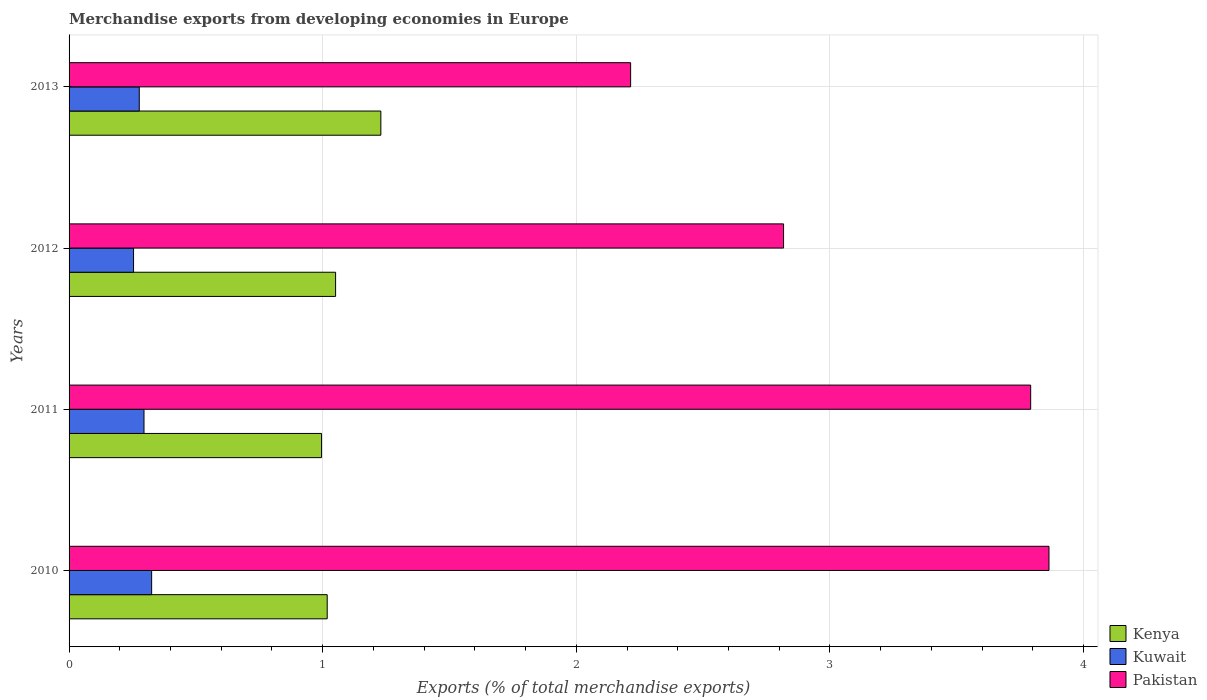How many different coloured bars are there?
Offer a very short reply. 3. Are the number of bars per tick equal to the number of legend labels?
Keep it short and to the point. Yes. How many bars are there on the 3rd tick from the bottom?
Your response must be concise. 3. What is the percentage of total merchandise exports in Pakistan in 2013?
Give a very brief answer. 2.21. Across all years, what is the maximum percentage of total merchandise exports in Kenya?
Offer a terse response. 1.23. Across all years, what is the minimum percentage of total merchandise exports in Kenya?
Give a very brief answer. 1. In which year was the percentage of total merchandise exports in Kuwait maximum?
Keep it short and to the point. 2010. In which year was the percentage of total merchandise exports in Kenya minimum?
Ensure brevity in your answer.  2011. What is the total percentage of total merchandise exports in Pakistan in the graph?
Your response must be concise. 12.69. What is the difference between the percentage of total merchandise exports in Kuwait in 2011 and that in 2012?
Ensure brevity in your answer.  0.04. What is the difference between the percentage of total merchandise exports in Kuwait in 2010 and the percentage of total merchandise exports in Kenya in 2012?
Your response must be concise. -0.73. What is the average percentage of total merchandise exports in Kenya per year?
Keep it short and to the point. 1.07. In the year 2013, what is the difference between the percentage of total merchandise exports in Kenya and percentage of total merchandise exports in Kuwait?
Provide a succinct answer. 0.95. In how many years, is the percentage of total merchandise exports in Kenya greater than 3.2 %?
Your answer should be compact. 0. What is the ratio of the percentage of total merchandise exports in Pakistan in 2012 to that in 2013?
Your answer should be very brief. 1.27. What is the difference between the highest and the second highest percentage of total merchandise exports in Kuwait?
Give a very brief answer. 0.03. What is the difference between the highest and the lowest percentage of total merchandise exports in Kenya?
Provide a succinct answer. 0.23. Is the sum of the percentage of total merchandise exports in Kenya in 2011 and 2012 greater than the maximum percentage of total merchandise exports in Kuwait across all years?
Provide a short and direct response. Yes. What does the 3rd bar from the top in 2013 represents?
Your answer should be compact. Kenya. What does the 3rd bar from the bottom in 2011 represents?
Offer a very short reply. Pakistan. Is it the case that in every year, the sum of the percentage of total merchandise exports in Kenya and percentage of total merchandise exports in Kuwait is greater than the percentage of total merchandise exports in Pakistan?
Provide a succinct answer. No. Are all the bars in the graph horizontal?
Provide a succinct answer. Yes. What is the difference between two consecutive major ticks on the X-axis?
Make the answer very short. 1. Are the values on the major ticks of X-axis written in scientific E-notation?
Make the answer very short. No. How are the legend labels stacked?
Your answer should be very brief. Vertical. What is the title of the graph?
Make the answer very short. Merchandise exports from developing economies in Europe. Does "Turks and Caicos Islands" appear as one of the legend labels in the graph?
Provide a short and direct response. No. What is the label or title of the X-axis?
Offer a terse response. Exports (% of total merchandise exports). What is the label or title of the Y-axis?
Ensure brevity in your answer.  Years. What is the Exports (% of total merchandise exports) in Kenya in 2010?
Keep it short and to the point. 1.02. What is the Exports (% of total merchandise exports) of Kuwait in 2010?
Give a very brief answer. 0.33. What is the Exports (% of total merchandise exports) in Pakistan in 2010?
Give a very brief answer. 3.86. What is the Exports (% of total merchandise exports) in Kenya in 2011?
Provide a succinct answer. 1. What is the Exports (% of total merchandise exports) in Kuwait in 2011?
Your response must be concise. 0.3. What is the Exports (% of total merchandise exports) of Pakistan in 2011?
Your answer should be compact. 3.79. What is the Exports (% of total merchandise exports) of Kenya in 2012?
Your response must be concise. 1.05. What is the Exports (% of total merchandise exports) in Kuwait in 2012?
Keep it short and to the point. 0.25. What is the Exports (% of total merchandise exports) of Pakistan in 2012?
Offer a very short reply. 2.82. What is the Exports (% of total merchandise exports) in Kenya in 2013?
Your response must be concise. 1.23. What is the Exports (% of total merchandise exports) in Kuwait in 2013?
Offer a terse response. 0.28. What is the Exports (% of total merchandise exports) of Pakistan in 2013?
Your answer should be compact. 2.21. Across all years, what is the maximum Exports (% of total merchandise exports) of Kenya?
Keep it short and to the point. 1.23. Across all years, what is the maximum Exports (% of total merchandise exports) of Kuwait?
Offer a very short reply. 0.33. Across all years, what is the maximum Exports (% of total merchandise exports) in Pakistan?
Provide a short and direct response. 3.86. Across all years, what is the minimum Exports (% of total merchandise exports) in Kenya?
Make the answer very short. 1. Across all years, what is the minimum Exports (% of total merchandise exports) of Kuwait?
Offer a very short reply. 0.25. Across all years, what is the minimum Exports (% of total merchandise exports) of Pakistan?
Your answer should be compact. 2.21. What is the total Exports (% of total merchandise exports) of Kenya in the graph?
Provide a short and direct response. 4.29. What is the total Exports (% of total merchandise exports) in Kuwait in the graph?
Offer a very short reply. 1.15. What is the total Exports (% of total merchandise exports) of Pakistan in the graph?
Make the answer very short. 12.69. What is the difference between the Exports (% of total merchandise exports) of Kenya in 2010 and that in 2011?
Your answer should be very brief. 0.02. What is the difference between the Exports (% of total merchandise exports) in Kuwait in 2010 and that in 2011?
Your answer should be compact. 0.03. What is the difference between the Exports (% of total merchandise exports) in Pakistan in 2010 and that in 2011?
Provide a short and direct response. 0.07. What is the difference between the Exports (% of total merchandise exports) of Kenya in 2010 and that in 2012?
Offer a very short reply. -0.03. What is the difference between the Exports (% of total merchandise exports) in Kuwait in 2010 and that in 2012?
Your answer should be compact. 0.07. What is the difference between the Exports (% of total merchandise exports) in Pakistan in 2010 and that in 2012?
Offer a very short reply. 1.05. What is the difference between the Exports (% of total merchandise exports) in Kenya in 2010 and that in 2013?
Give a very brief answer. -0.21. What is the difference between the Exports (% of total merchandise exports) in Kuwait in 2010 and that in 2013?
Offer a terse response. 0.05. What is the difference between the Exports (% of total merchandise exports) in Pakistan in 2010 and that in 2013?
Provide a short and direct response. 1.65. What is the difference between the Exports (% of total merchandise exports) of Kenya in 2011 and that in 2012?
Provide a short and direct response. -0.06. What is the difference between the Exports (% of total merchandise exports) in Kuwait in 2011 and that in 2012?
Provide a succinct answer. 0.04. What is the difference between the Exports (% of total merchandise exports) in Pakistan in 2011 and that in 2012?
Your response must be concise. 0.97. What is the difference between the Exports (% of total merchandise exports) in Kenya in 2011 and that in 2013?
Your response must be concise. -0.23. What is the difference between the Exports (% of total merchandise exports) of Kuwait in 2011 and that in 2013?
Your answer should be compact. 0.02. What is the difference between the Exports (% of total merchandise exports) of Pakistan in 2011 and that in 2013?
Ensure brevity in your answer.  1.58. What is the difference between the Exports (% of total merchandise exports) of Kenya in 2012 and that in 2013?
Give a very brief answer. -0.18. What is the difference between the Exports (% of total merchandise exports) in Kuwait in 2012 and that in 2013?
Give a very brief answer. -0.02. What is the difference between the Exports (% of total merchandise exports) of Pakistan in 2012 and that in 2013?
Give a very brief answer. 0.6. What is the difference between the Exports (% of total merchandise exports) in Kenya in 2010 and the Exports (% of total merchandise exports) in Kuwait in 2011?
Keep it short and to the point. 0.72. What is the difference between the Exports (% of total merchandise exports) of Kenya in 2010 and the Exports (% of total merchandise exports) of Pakistan in 2011?
Make the answer very short. -2.77. What is the difference between the Exports (% of total merchandise exports) of Kuwait in 2010 and the Exports (% of total merchandise exports) of Pakistan in 2011?
Make the answer very short. -3.47. What is the difference between the Exports (% of total merchandise exports) of Kenya in 2010 and the Exports (% of total merchandise exports) of Kuwait in 2012?
Provide a succinct answer. 0.76. What is the difference between the Exports (% of total merchandise exports) of Kenya in 2010 and the Exports (% of total merchandise exports) of Pakistan in 2012?
Your answer should be very brief. -1.8. What is the difference between the Exports (% of total merchandise exports) of Kuwait in 2010 and the Exports (% of total merchandise exports) of Pakistan in 2012?
Your answer should be very brief. -2.49. What is the difference between the Exports (% of total merchandise exports) of Kenya in 2010 and the Exports (% of total merchandise exports) of Kuwait in 2013?
Ensure brevity in your answer.  0.74. What is the difference between the Exports (% of total merchandise exports) in Kenya in 2010 and the Exports (% of total merchandise exports) in Pakistan in 2013?
Offer a terse response. -1.2. What is the difference between the Exports (% of total merchandise exports) of Kuwait in 2010 and the Exports (% of total merchandise exports) of Pakistan in 2013?
Offer a very short reply. -1.89. What is the difference between the Exports (% of total merchandise exports) of Kenya in 2011 and the Exports (% of total merchandise exports) of Kuwait in 2012?
Offer a very short reply. 0.74. What is the difference between the Exports (% of total merchandise exports) in Kenya in 2011 and the Exports (% of total merchandise exports) in Pakistan in 2012?
Make the answer very short. -1.82. What is the difference between the Exports (% of total merchandise exports) in Kuwait in 2011 and the Exports (% of total merchandise exports) in Pakistan in 2012?
Provide a succinct answer. -2.52. What is the difference between the Exports (% of total merchandise exports) of Kenya in 2011 and the Exports (% of total merchandise exports) of Kuwait in 2013?
Provide a short and direct response. 0.72. What is the difference between the Exports (% of total merchandise exports) in Kenya in 2011 and the Exports (% of total merchandise exports) in Pakistan in 2013?
Your response must be concise. -1.22. What is the difference between the Exports (% of total merchandise exports) in Kuwait in 2011 and the Exports (% of total merchandise exports) in Pakistan in 2013?
Your answer should be very brief. -1.92. What is the difference between the Exports (% of total merchandise exports) in Kenya in 2012 and the Exports (% of total merchandise exports) in Kuwait in 2013?
Your answer should be very brief. 0.77. What is the difference between the Exports (% of total merchandise exports) of Kenya in 2012 and the Exports (% of total merchandise exports) of Pakistan in 2013?
Ensure brevity in your answer.  -1.16. What is the difference between the Exports (% of total merchandise exports) in Kuwait in 2012 and the Exports (% of total merchandise exports) in Pakistan in 2013?
Your answer should be compact. -1.96. What is the average Exports (% of total merchandise exports) of Kenya per year?
Give a very brief answer. 1.07. What is the average Exports (% of total merchandise exports) of Kuwait per year?
Ensure brevity in your answer.  0.29. What is the average Exports (% of total merchandise exports) in Pakistan per year?
Your answer should be compact. 3.17. In the year 2010, what is the difference between the Exports (% of total merchandise exports) in Kenya and Exports (% of total merchandise exports) in Kuwait?
Your response must be concise. 0.69. In the year 2010, what is the difference between the Exports (% of total merchandise exports) of Kenya and Exports (% of total merchandise exports) of Pakistan?
Provide a succinct answer. -2.85. In the year 2010, what is the difference between the Exports (% of total merchandise exports) of Kuwait and Exports (% of total merchandise exports) of Pakistan?
Give a very brief answer. -3.54. In the year 2011, what is the difference between the Exports (% of total merchandise exports) in Kenya and Exports (% of total merchandise exports) in Pakistan?
Keep it short and to the point. -2.8. In the year 2011, what is the difference between the Exports (% of total merchandise exports) in Kuwait and Exports (% of total merchandise exports) in Pakistan?
Ensure brevity in your answer.  -3.5. In the year 2012, what is the difference between the Exports (% of total merchandise exports) of Kenya and Exports (% of total merchandise exports) of Kuwait?
Ensure brevity in your answer.  0.8. In the year 2012, what is the difference between the Exports (% of total merchandise exports) in Kenya and Exports (% of total merchandise exports) in Pakistan?
Keep it short and to the point. -1.77. In the year 2012, what is the difference between the Exports (% of total merchandise exports) in Kuwait and Exports (% of total merchandise exports) in Pakistan?
Offer a very short reply. -2.56. In the year 2013, what is the difference between the Exports (% of total merchandise exports) in Kenya and Exports (% of total merchandise exports) in Kuwait?
Make the answer very short. 0.95. In the year 2013, what is the difference between the Exports (% of total merchandise exports) of Kenya and Exports (% of total merchandise exports) of Pakistan?
Ensure brevity in your answer.  -0.98. In the year 2013, what is the difference between the Exports (% of total merchandise exports) of Kuwait and Exports (% of total merchandise exports) of Pakistan?
Ensure brevity in your answer.  -1.94. What is the ratio of the Exports (% of total merchandise exports) of Kenya in 2010 to that in 2011?
Give a very brief answer. 1.02. What is the ratio of the Exports (% of total merchandise exports) of Kuwait in 2010 to that in 2011?
Make the answer very short. 1.1. What is the ratio of the Exports (% of total merchandise exports) in Kenya in 2010 to that in 2012?
Your answer should be very brief. 0.97. What is the ratio of the Exports (% of total merchandise exports) of Kuwait in 2010 to that in 2012?
Your answer should be compact. 1.28. What is the ratio of the Exports (% of total merchandise exports) in Pakistan in 2010 to that in 2012?
Offer a terse response. 1.37. What is the ratio of the Exports (% of total merchandise exports) of Kenya in 2010 to that in 2013?
Ensure brevity in your answer.  0.83. What is the ratio of the Exports (% of total merchandise exports) of Kuwait in 2010 to that in 2013?
Your response must be concise. 1.18. What is the ratio of the Exports (% of total merchandise exports) in Pakistan in 2010 to that in 2013?
Keep it short and to the point. 1.75. What is the ratio of the Exports (% of total merchandise exports) of Kenya in 2011 to that in 2012?
Make the answer very short. 0.95. What is the ratio of the Exports (% of total merchandise exports) of Kuwait in 2011 to that in 2012?
Keep it short and to the point. 1.16. What is the ratio of the Exports (% of total merchandise exports) of Pakistan in 2011 to that in 2012?
Give a very brief answer. 1.35. What is the ratio of the Exports (% of total merchandise exports) in Kenya in 2011 to that in 2013?
Your response must be concise. 0.81. What is the ratio of the Exports (% of total merchandise exports) of Kuwait in 2011 to that in 2013?
Offer a very short reply. 1.07. What is the ratio of the Exports (% of total merchandise exports) of Pakistan in 2011 to that in 2013?
Make the answer very short. 1.71. What is the ratio of the Exports (% of total merchandise exports) in Kenya in 2012 to that in 2013?
Provide a succinct answer. 0.85. What is the ratio of the Exports (% of total merchandise exports) in Kuwait in 2012 to that in 2013?
Keep it short and to the point. 0.92. What is the ratio of the Exports (% of total merchandise exports) of Pakistan in 2012 to that in 2013?
Offer a terse response. 1.27. What is the difference between the highest and the second highest Exports (% of total merchandise exports) of Kenya?
Ensure brevity in your answer.  0.18. What is the difference between the highest and the second highest Exports (% of total merchandise exports) of Kuwait?
Keep it short and to the point. 0.03. What is the difference between the highest and the second highest Exports (% of total merchandise exports) of Pakistan?
Provide a short and direct response. 0.07. What is the difference between the highest and the lowest Exports (% of total merchandise exports) in Kenya?
Offer a terse response. 0.23. What is the difference between the highest and the lowest Exports (% of total merchandise exports) in Kuwait?
Ensure brevity in your answer.  0.07. What is the difference between the highest and the lowest Exports (% of total merchandise exports) in Pakistan?
Provide a succinct answer. 1.65. 